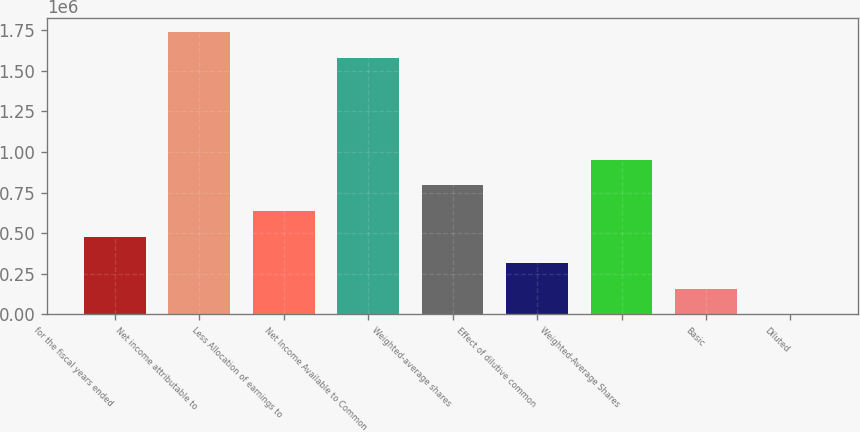<chart> <loc_0><loc_0><loc_500><loc_500><bar_chart><fcel>for the fiscal years ended<fcel>Net income attributable to<fcel>Less Allocation of earnings to<fcel>Net Income Available to Common<fcel>Weighted-average shares<fcel>Effect of dilutive common<fcel>Weighted-Average Shares<fcel>Basic<fcel>Diluted<nl><fcel>476469<fcel>1.73711e+06<fcel>635289<fcel>1.57829e+06<fcel>794110<fcel>317648<fcel>952930<fcel>158827<fcel>6.62<nl></chart> 